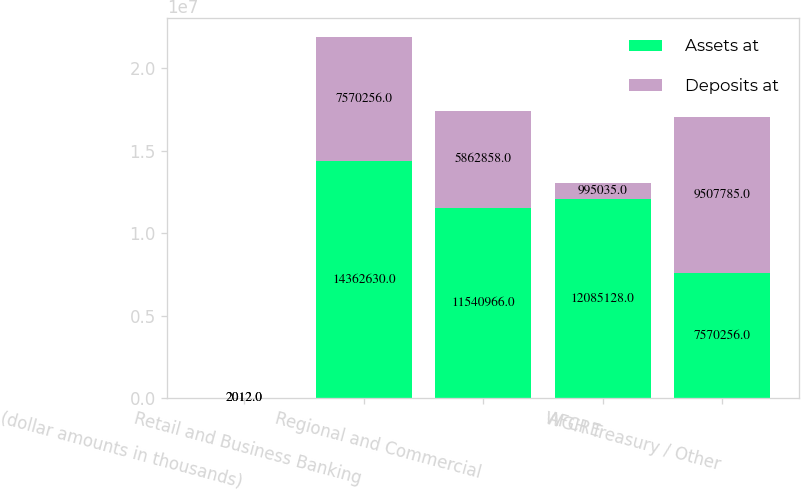Convert chart. <chart><loc_0><loc_0><loc_500><loc_500><stacked_bar_chart><ecel><fcel>(dollar amounts in thousands)<fcel>Retail and Business Banking<fcel>Regional and Commercial<fcel>AFCRE<fcel>WGH Treasury / Other<nl><fcel>Assets at<fcel>2012<fcel>1.43626e+07<fcel>1.1541e+07<fcel>1.20851e+07<fcel>7.57026e+06<nl><fcel>Deposits at<fcel>2012<fcel>7.57026e+06<fcel>5.86286e+06<fcel>995035<fcel>9.50778e+06<nl></chart> 